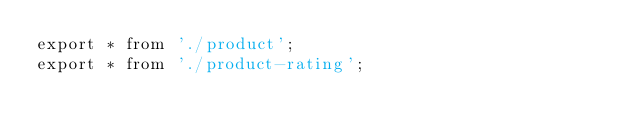<code> <loc_0><loc_0><loc_500><loc_500><_TypeScript_>export * from './product';
export * from './product-rating';
</code> 